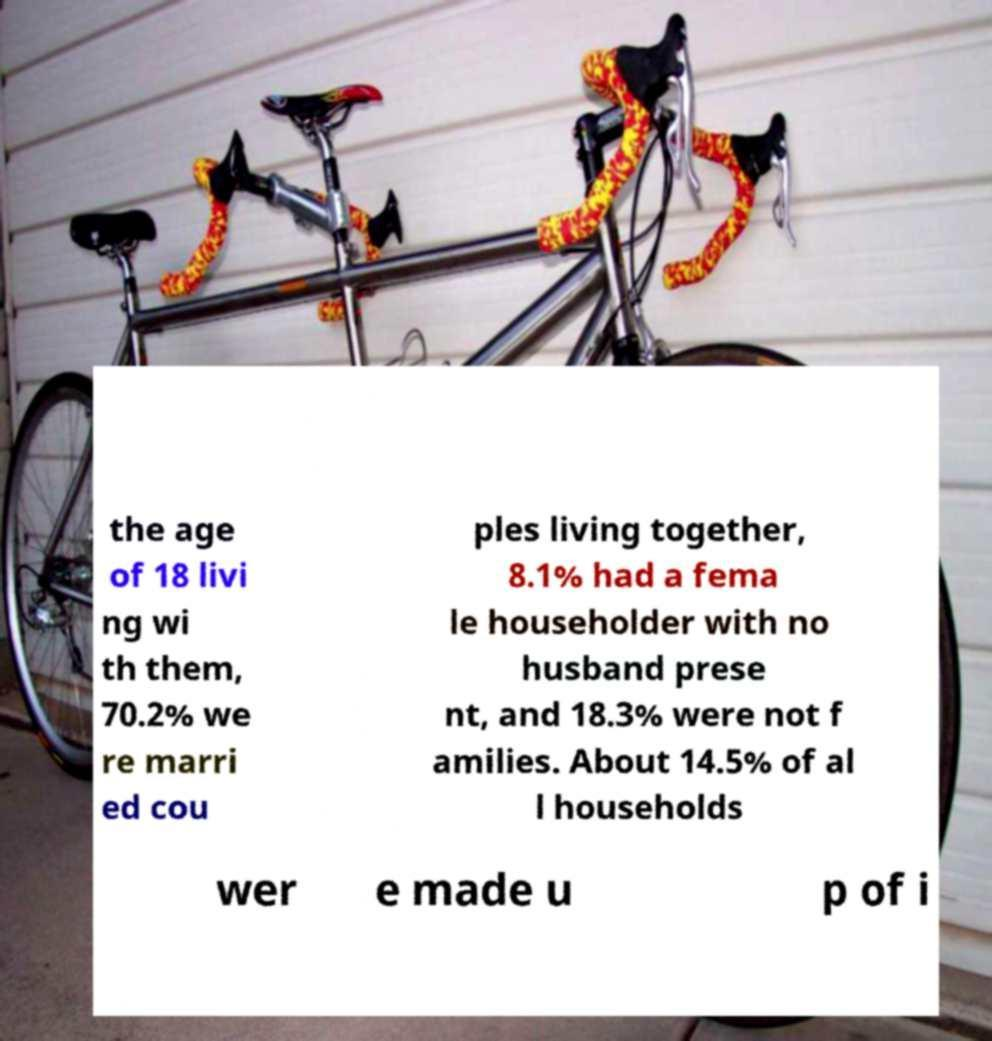For documentation purposes, I need the text within this image transcribed. Could you provide that? the age of 18 livi ng wi th them, 70.2% we re marri ed cou ples living together, 8.1% had a fema le householder with no husband prese nt, and 18.3% were not f amilies. About 14.5% of al l households wer e made u p of i 